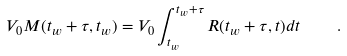Convert formula to latex. <formula><loc_0><loc_0><loc_500><loc_500>V _ { 0 } M ( t _ { w } + \tau , t _ { w } ) = V _ { 0 } \int _ { t _ { w } } ^ { t _ { w } + \tau } R ( t _ { w } + \tau , t ) d t \quad .</formula> 